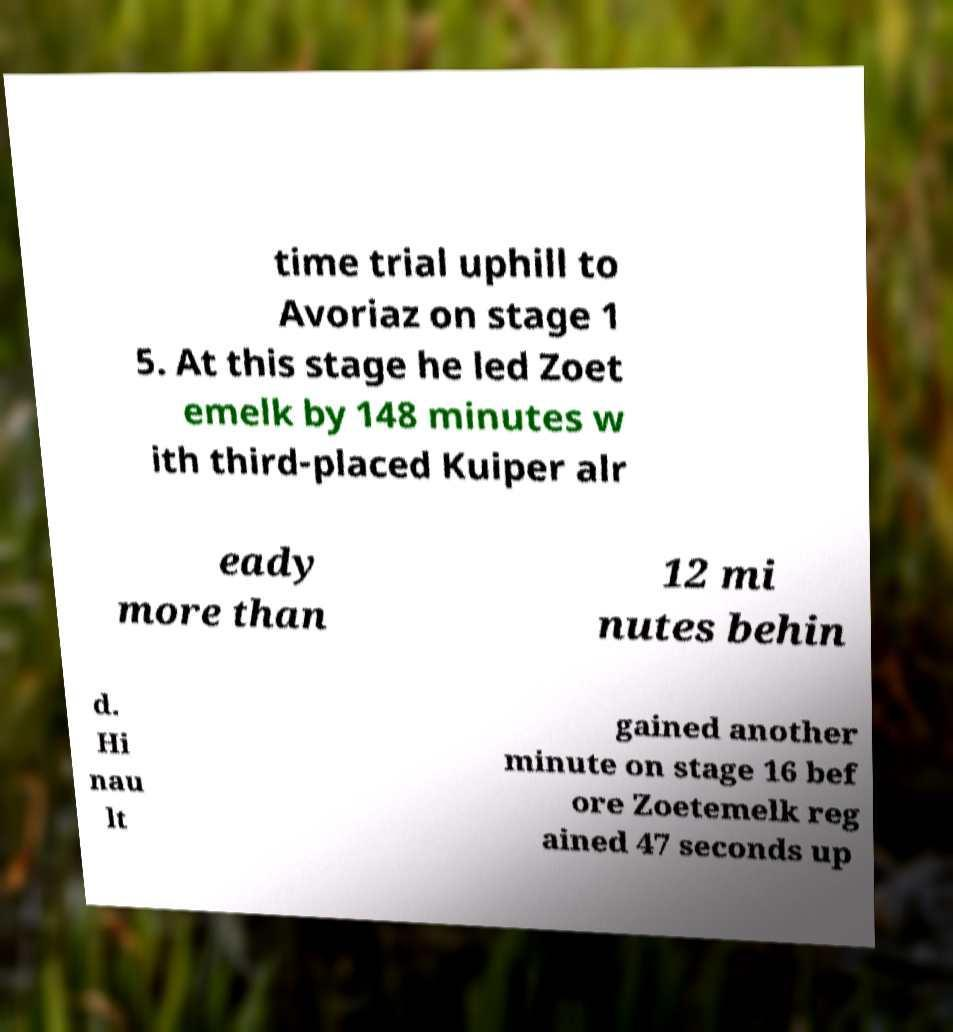Can you accurately transcribe the text from the provided image for me? time trial uphill to Avoriaz on stage 1 5. At this stage he led Zoet emelk by 148 minutes w ith third-placed Kuiper alr eady more than 12 mi nutes behin d. Hi nau lt gained another minute on stage 16 bef ore Zoetemelk reg ained 47 seconds up 